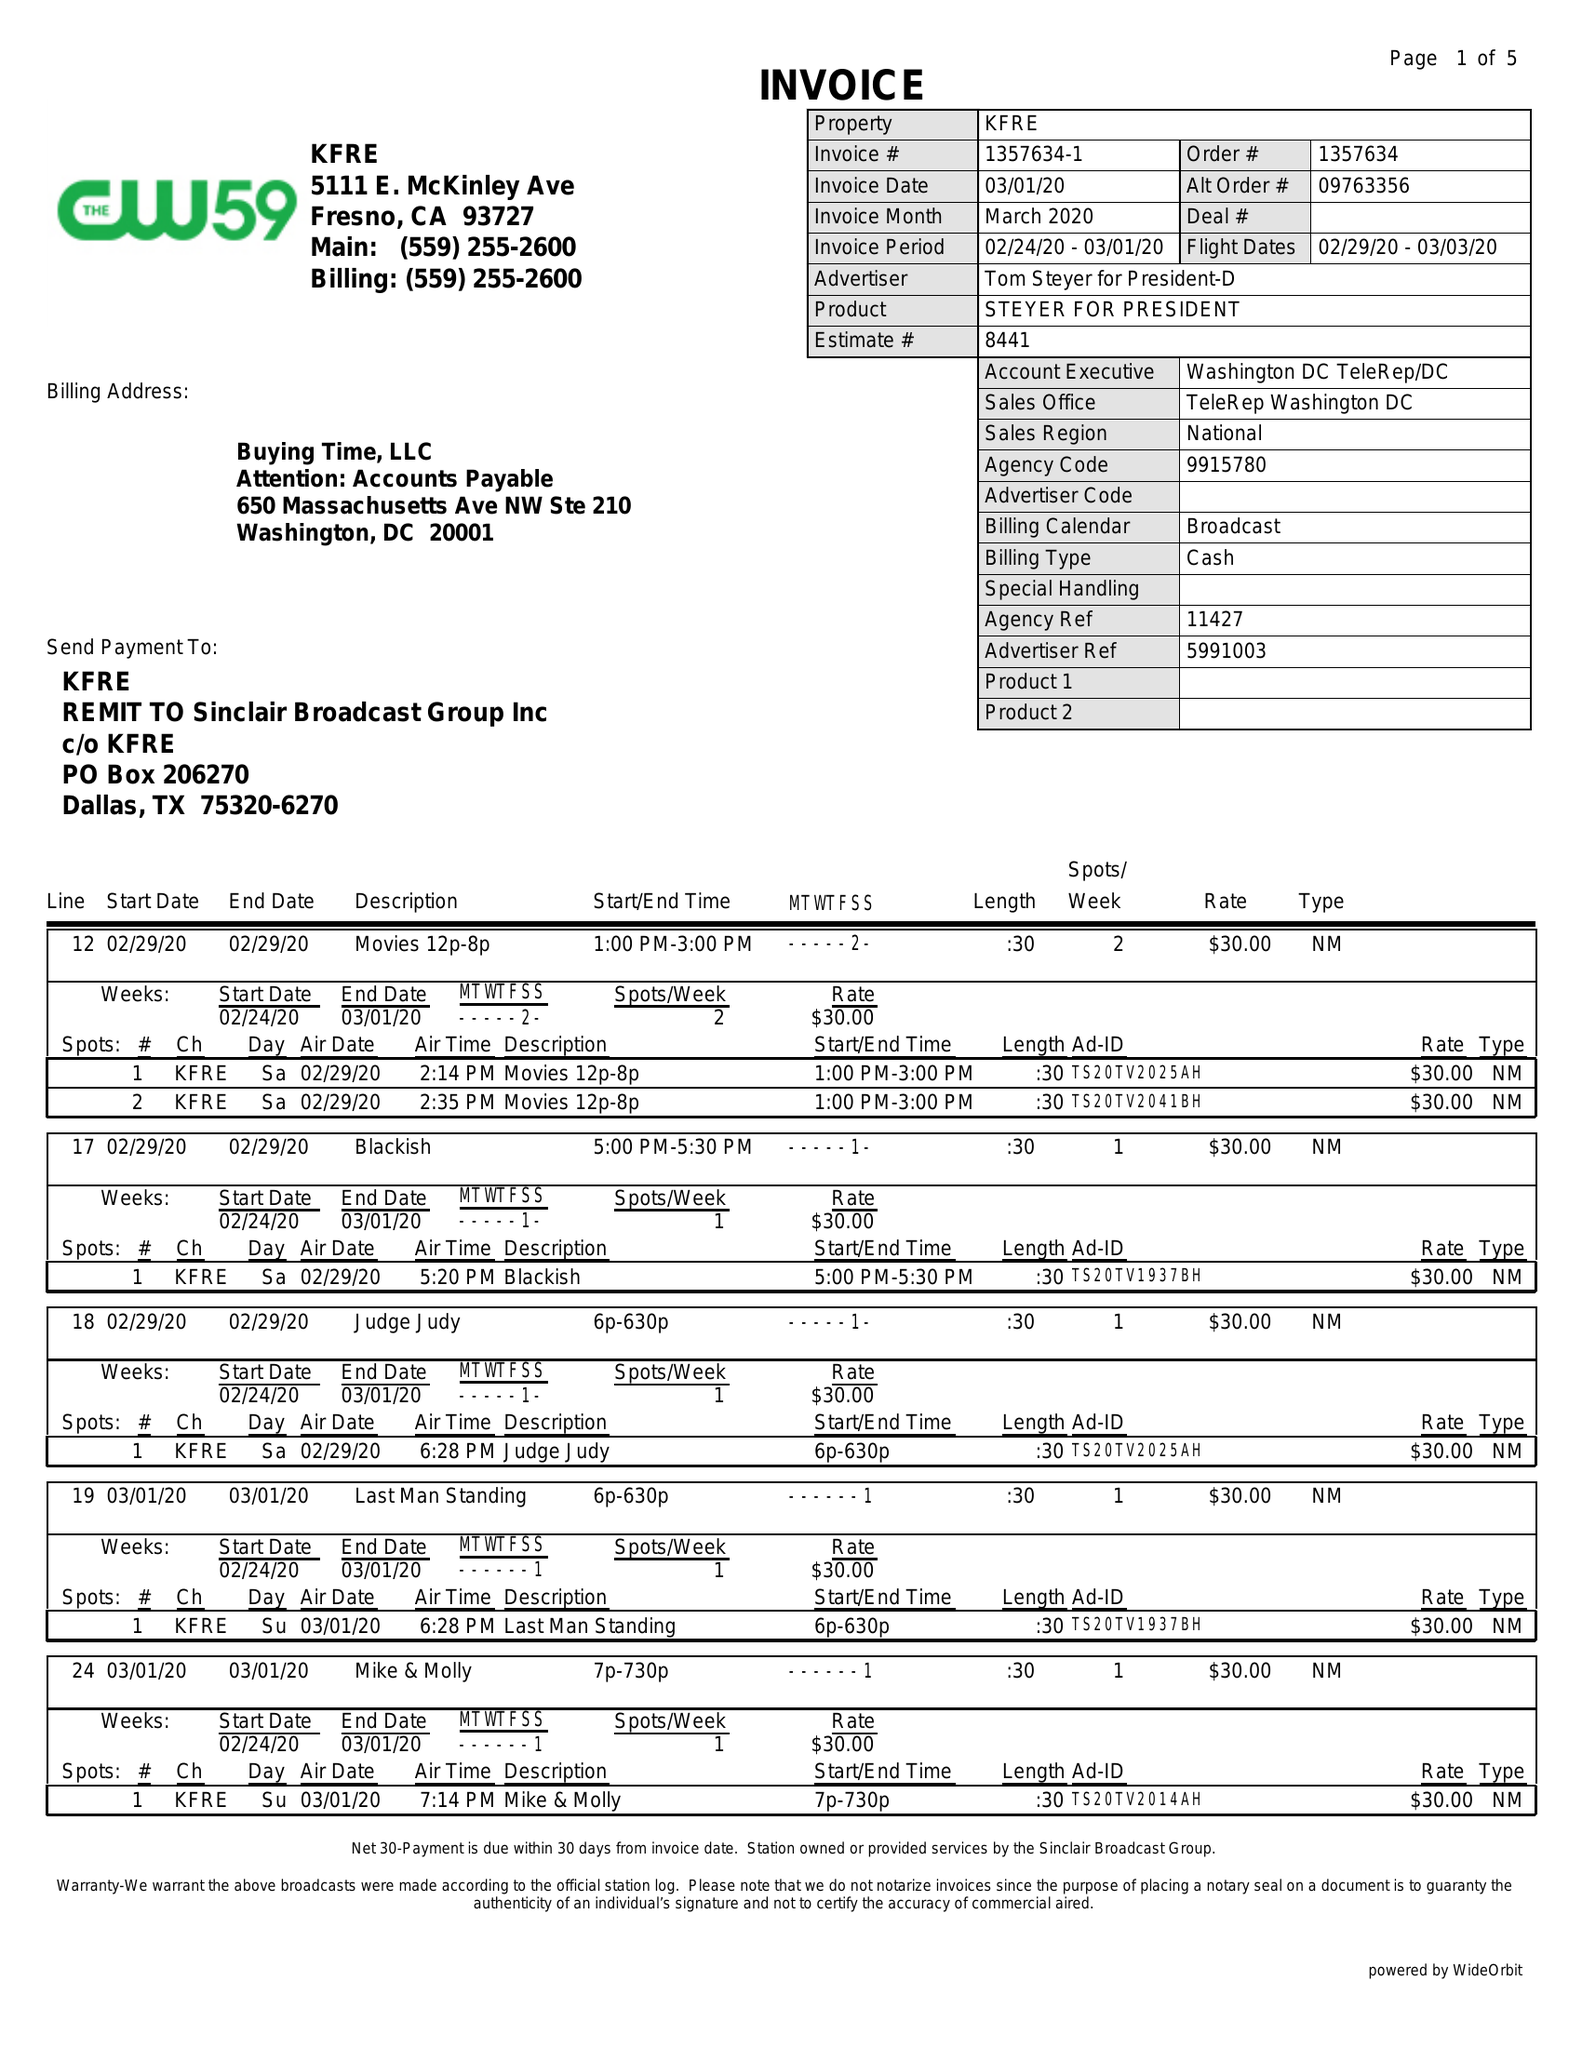What is the value for the flight_from?
Answer the question using a single word or phrase. 02/29/20 